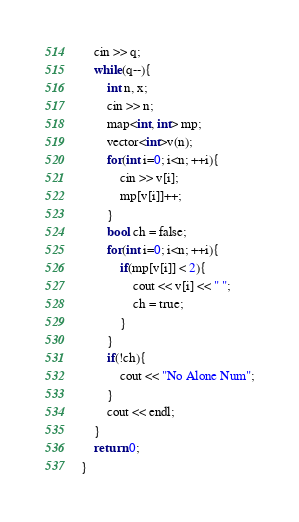Convert code to text. <code><loc_0><loc_0><loc_500><loc_500><_C++_>	cin >> q;
	while(q--){
		int n, x;
		cin >> n;
		map<int, int> mp;
		vector<int>v(n);
		for(int i=0; i<n; ++i){
			cin >> v[i];
			mp[v[i]]++;
		}
		bool ch = false;
		for(int i=0; i<n; ++i){
			if(mp[v[i]] < 2){
				cout << v[i] << " ";
				ch = true;
			}	
		}
		if(!ch){
			cout << "No Alone Num";
		}
		cout << endl;
	}
	return 0;
}
</code> 